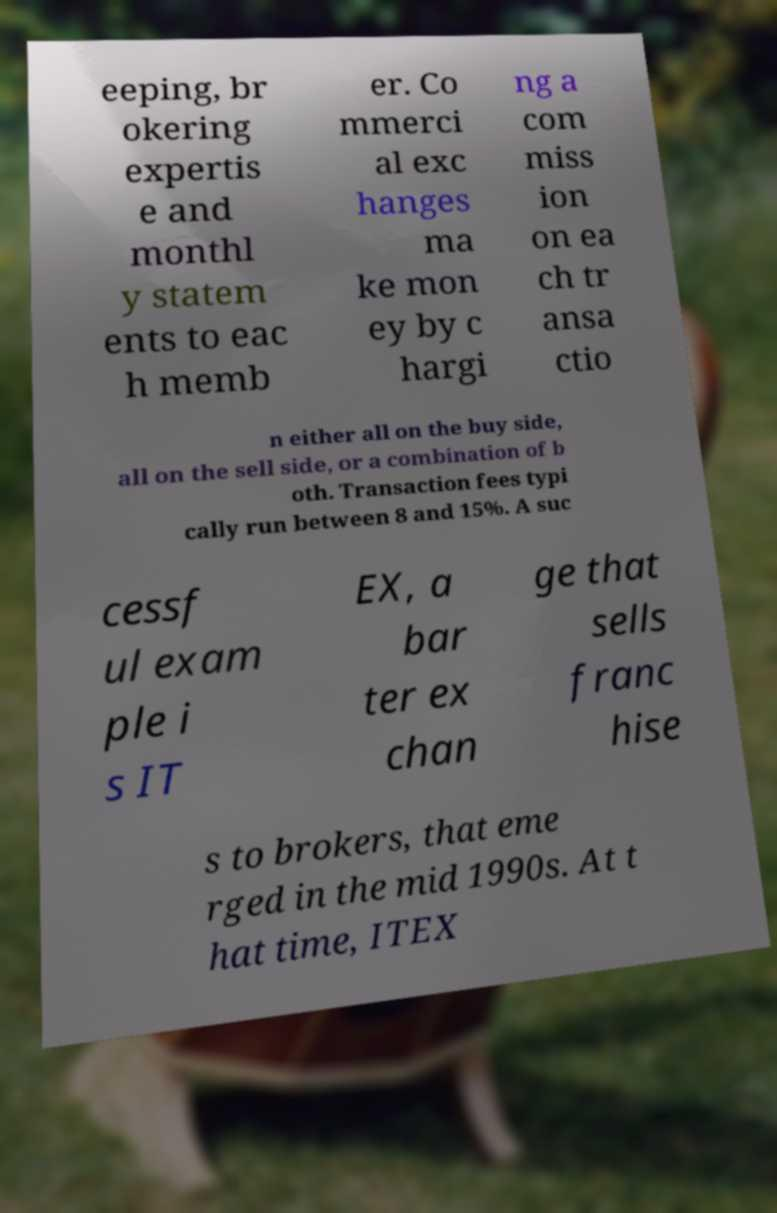Can you read and provide the text displayed in the image?This photo seems to have some interesting text. Can you extract and type it out for me? eeping, br okering expertis e and monthl y statem ents to eac h memb er. Co mmerci al exc hanges ma ke mon ey by c hargi ng a com miss ion on ea ch tr ansa ctio n either all on the buy side, all on the sell side, or a combination of b oth. Transaction fees typi cally run between 8 and 15%. A suc cessf ul exam ple i s IT EX, a bar ter ex chan ge that sells franc hise s to brokers, that eme rged in the mid 1990s. At t hat time, ITEX 